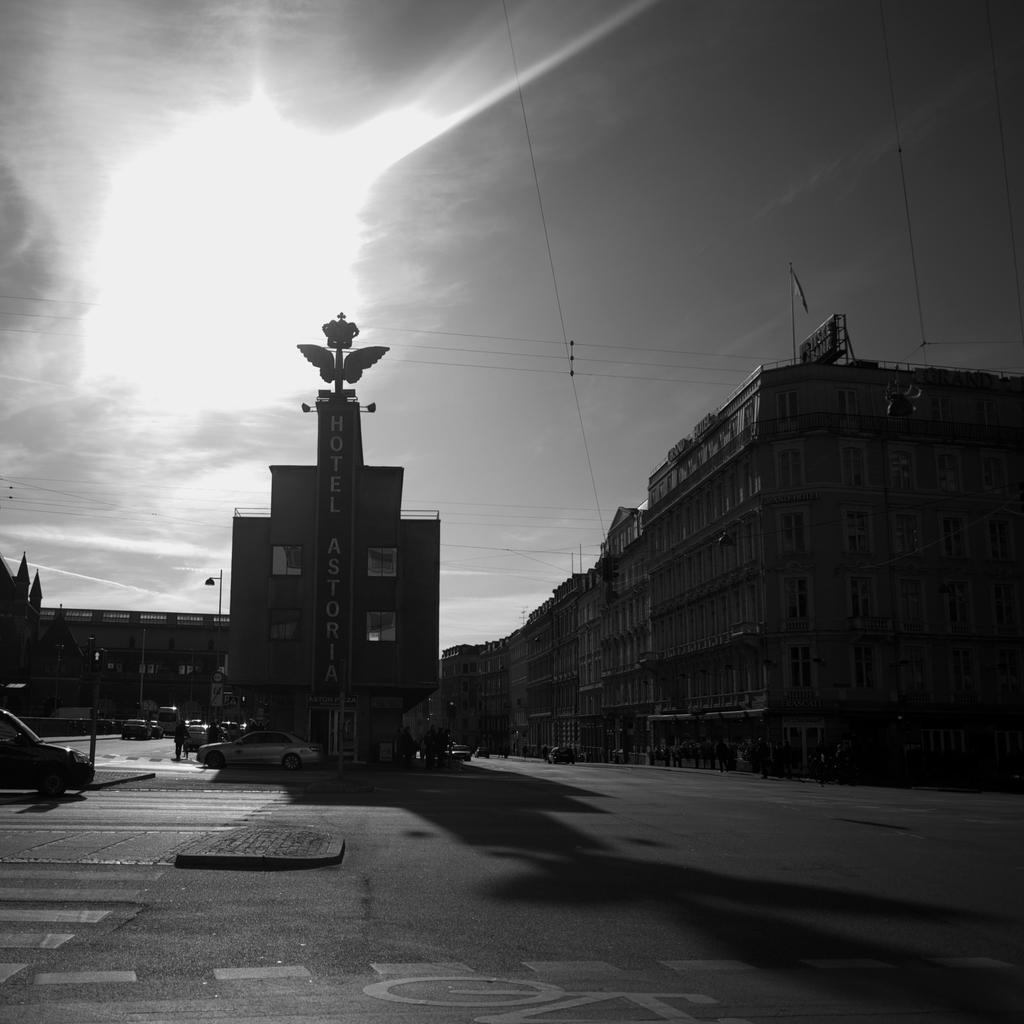Describe this image in one or two sentences. In this image I can see buildings and vehicles on the road. In the background I can see the sun, the sky and wires. This picture is black and white in color. 